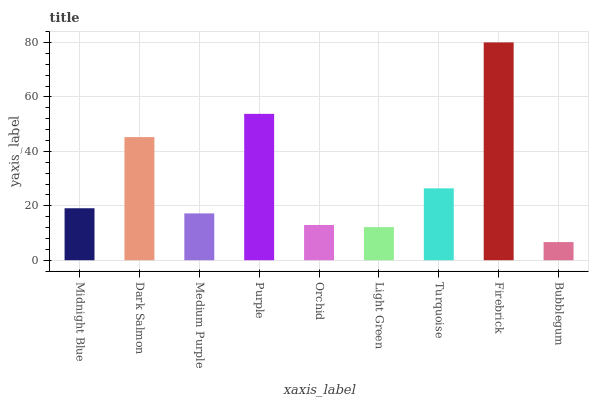Is Bubblegum the minimum?
Answer yes or no. Yes. Is Firebrick the maximum?
Answer yes or no. Yes. Is Dark Salmon the minimum?
Answer yes or no. No. Is Dark Salmon the maximum?
Answer yes or no. No. Is Dark Salmon greater than Midnight Blue?
Answer yes or no. Yes. Is Midnight Blue less than Dark Salmon?
Answer yes or no. Yes. Is Midnight Blue greater than Dark Salmon?
Answer yes or no. No. Is Dark Salmon less than Midnight Blue?
Answer yes or no. No. Is Midnight Blue the high median?
Answer yes or no. Yes. Is Midnight Blue the low median?
Answer yes or no. Yes. Is Firebrick the high median?
Answer yes or no. No. Is Firebrick the low median?
Answer yes or no. No. 